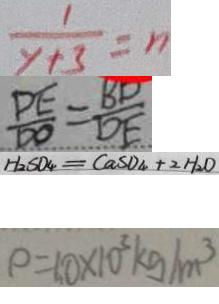<formula> <loc_0><loc_0><loc_500><loc_500>\frac { 1 } { y + 3 } = n 
 \frac { D E } { D O } = \frac { B D } { D E } 
 H _ { 2 } S O _ { 4 } = C a S O _ { 4 } + 2 H _ { 2 } O 
 \rho = 1 0 \times 1 0 ^ { 3 } k g / m ^ { 3 }</formula> 